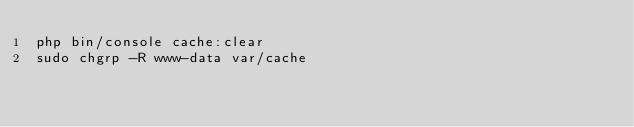<code> <loc_0><loc_0><loc_500><loc_500><_Bash_>php bin/console cache:clear
sudo chgrp -R www-data var/cache
</code> 